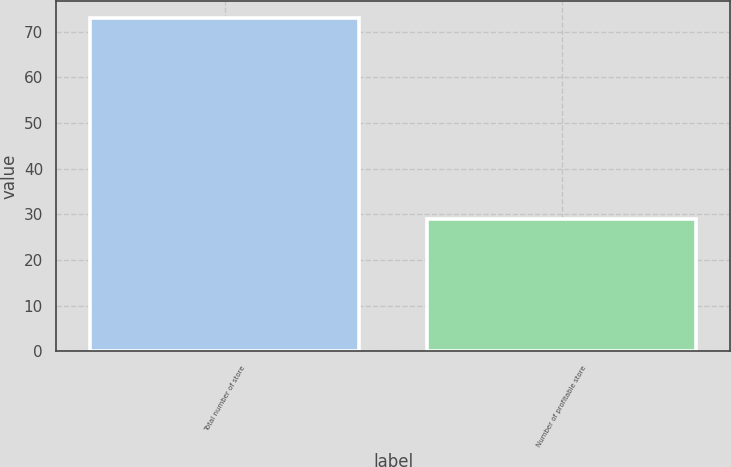Convert chart to OTSL. <chart><loc_0><loc_0><loc_500><loc_500><bar_chart><fcel>Total number of store<fcel>Number of profitable store<nl><fcel>73<fcel>29<nl></chart> 